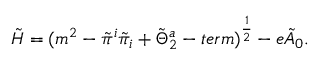Convert formula to latex. <formula><loc_0><loc_0><loc_500><loc_500>\tilde { H } = ( m ^ { 2 } - \tilde { \pi } ^ { i } \tilde { \pi } _ { i } + \tilde { \Theta } _ { 2 } ^ { a } - t e r m ) ^ { { \frac { 1 } { 2 } } } - e \tilde { A } _ { 0 } .</formula> 